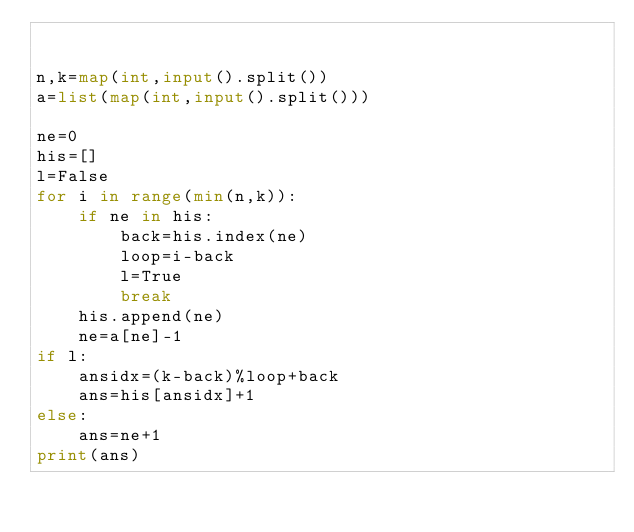<code> <loc_0><loc_0><loc_500><loc_500><_Python_>

n,k=map(int,input().split())
a=list(map(int,input().split()))

ne=0
his=[]
l=False
for i in range(min(n,k)):
    if ne in his:
        back=his.index(ne)
        loop=i-back
        l=True
        break
    his.append(ne)
    ne=a[ne]-1
if l:
    ansidx=(k-back)%loop+back
    ans=his[ansidx]+1
else:
    ans=ne+1
print(ans)</code> 